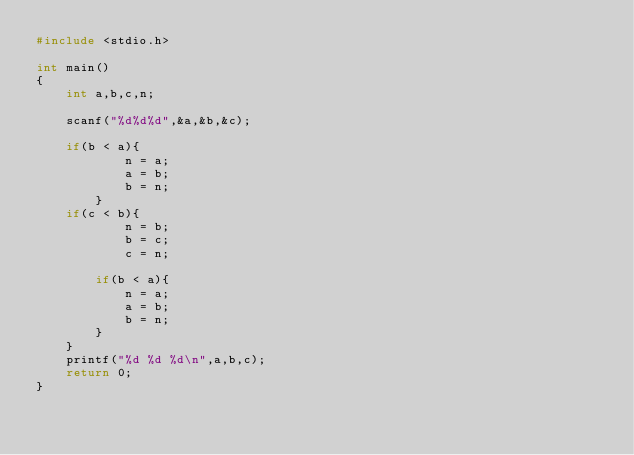Convert code to text. <code><loc_0><loc_0><loc_500><loc_500><_C_>#include <stdio.h>

int main()
{
    int a,b,c,n;
    
    scanf("%d%d%d",&a,&b,&c);
    
    if(b < a){
            n = a;
            a = b;
            b = n;
        }
    if(c < b){
            n = b;
            b = c;
            c = n;
            
        if(b < a){
            n = a;
            a = b;
            b = n;
        }
    }
    printf("%d %d %d\n",a,b,c);
    return 0;
}
</code> 